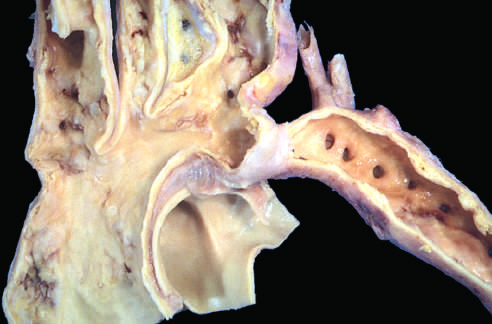s the coarctation a segmental narrowing of the aorta?
Answer the question using a single word or phrase. Yes 